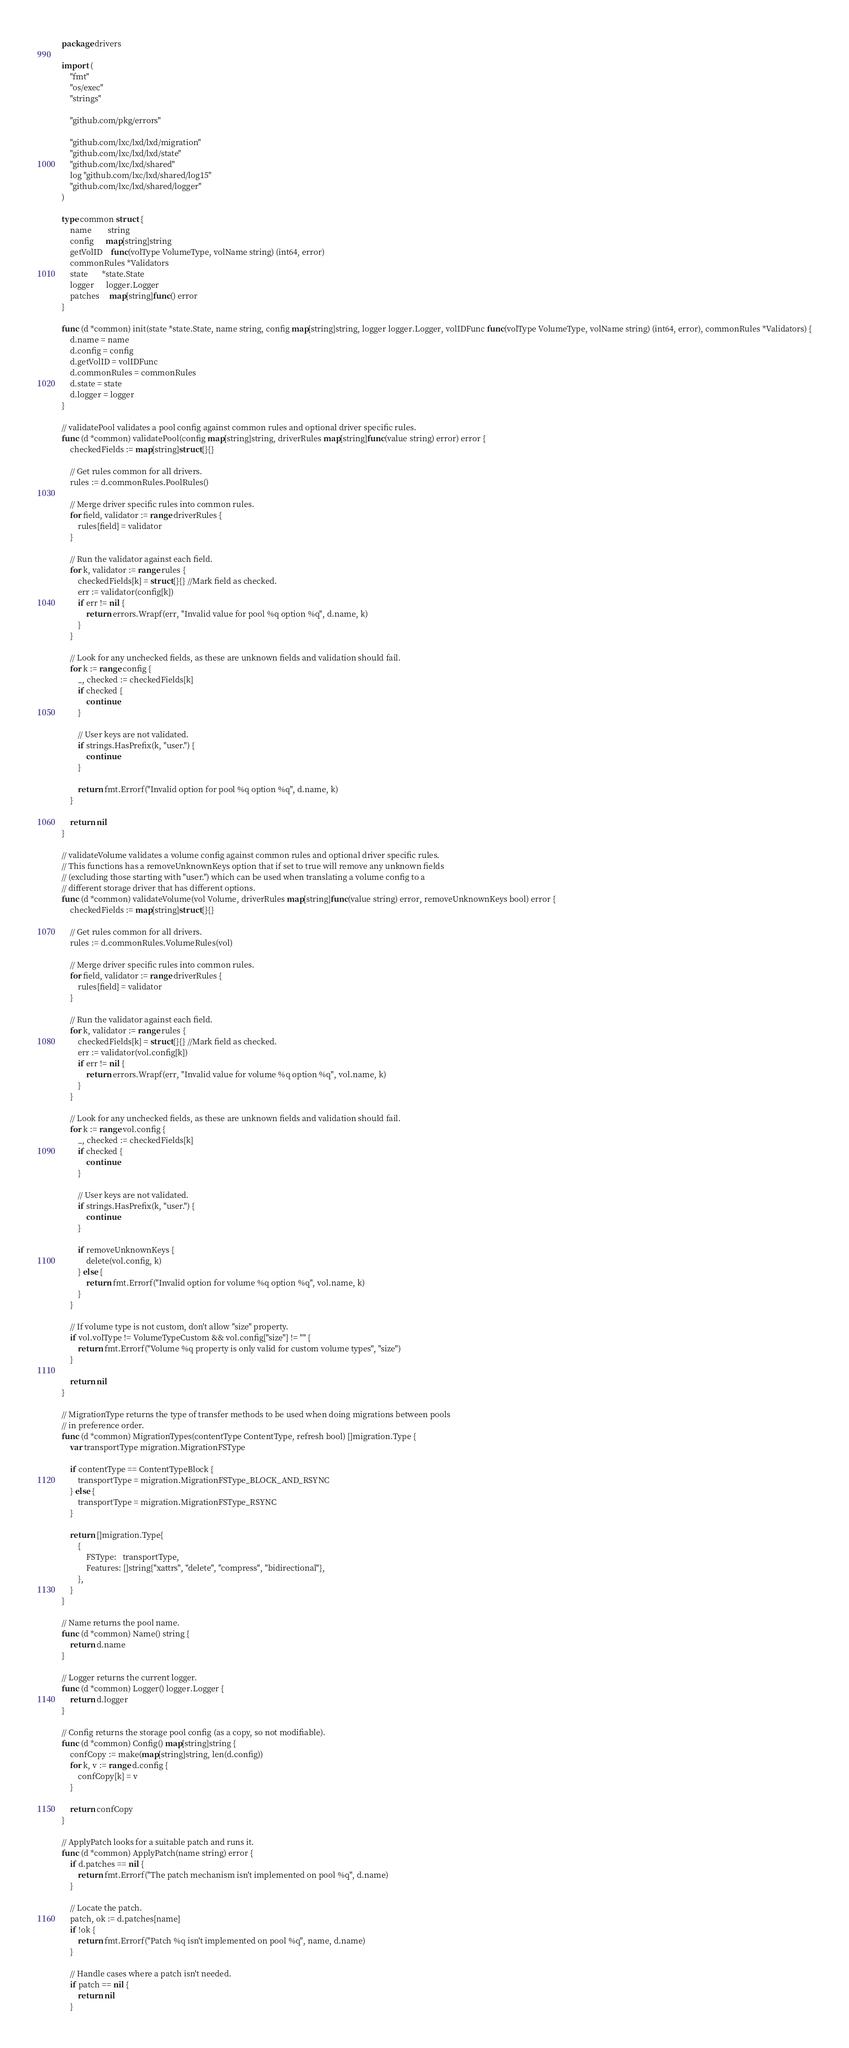Convert code to text. <code><loc_0><loc_0><loc_500><loc_500><_Go_>package drivers

import (
	"fmt"
	"os/exec"
	"strings"

	"github.com/pkg/errors"

	"github.com/lxc/lxd/lxd/migration"
	"github.com/lxc/lxd/lxd/state"
	"github.com/lxc/lxd/shared"
	log "github.com/lxc/lxd/shared/log15"
	"github.com/lxc/lxd/shared/logger"
)

type common struct {
	name        string
	config      map[string]string
	getVolID    func(volType VolumeType, volName string) (int64, error)
	commonRules *Validators
	state       *state.State
	logger      logger.Logger
	patches     map[string]func() error
}

func (d *common) init(state *state.State, name string, config map[string]string, logger logger.Logger, volIDFunc func(volType VolumeType, volName string) (int64, error), commonRules *Validators) {
	d.name = name
	d.config = config
	d.getVolID = volIDFunc
	d.commonRules = commonRules
	d.state = state
	d.logger = logger
}

// validatePool validates a pool config against common rules and optional driver specific rules.
func (d *common) validatePool(config map[string]string, driverRules map[string]func(value string) error) error {
	checkedFields := map[string]struct{}{}

	// Get rules common for all drivers.
	rules := d.commonRules.PoolRules()

	// Merge driver specific rules into common rules.
	for field, validator := range driverRules {
		rules[field] = validator
	}

	// Run the validator against each field.
	for k, validator := range rules {
		checkedFields[k] = struct{}{} //Mark field as checked.
		err := validator(config[k])
		if err != nil {
			return errors.Wrapf(err, "Invalid value for pool %q option %q", d.name, k)
		}
	}

	// Look for any unchecked fields, as these are unknown fields and validation should fail.
	for k := range config {
		_, checked := checkedFields[k]
		if checked {
			continue
		}

		// User keys are not validated.
		if strings.HasPrefix(k, "user.") {
			continue
		}

		return fmt.Errorf("Invalid option for pool %q option %q", d.name, k)
	}

	return nil
}

// validateVolume validates a volume config against common rules and optional driver specific rules.
// This functions has a removeUnknownKeys option that if set to true will remove any unknown fields
// (excluding those starting with "user.") which can be used when translating a volume config to a
// different storage driver that has different options.
func (d *common) validateVolume(vol Volume, driverRules map[string]func(value string) error, removeUnknownKeys bool) error {
	checkedFields := map[string]struct{}{}

	// Get rules common for all drivers.
	rules := d.commonRules.VolumeRules(vol)

	// Merge driver specific rules into common rules.
	for field, validator := range driverRules {
		rules[field] = validator
	}

	// Run the validator against each field.
	for k, validator := range rules {
		checkedFields[k] = struct{}{} //Mark field as checked.
		err := validator(vol.config[k])
		if err != nil {
			return errors.Wrapf(err, "Invalid value for volume %q option %q", vol.name, k)
		}
	}

	// Look for any unchecked fields, as these are unknown fields and validation should fail.
	for k := range vol.config {
		_, checked := checkedFields[k]
		if checked {
			continue
		}

		// User keys are not validated.
		if strings.HasPrefix(k, "user.") {
			continue
		}

		if removeUnknownKeys {
			delete(vol.config, k)
		} else {
			return fmt.Errorf("Invalid option for volume %q option %q", vol.name, k)
		}
	}

	// If volume type is not custom, don't allow "size" property.
	if vol.volType != VolumeTypeCustom && vol.config["size"] != "" {
		return fmt.Errorf("Volume %q property is only valid for custom volume types", "size")
	}

	return nil
}

// MigrationType returns the type of transfer methods to be used when doing migrations between pools
// in preference order.
func (d *common) MigrationTypes(contentType ContentType, refresh bool) []migration.Type {
	var transportType migration.MigrationFSType

	if contentType == ContentTypeBlock {
		transportType = migration.MigrationFSType_BLOCK_AND_RSYNC
	} else {
		transportType = migration.MigrationFSType_RSYNC
	}

	return []migration.Type{
		{
			FSType:   transportType,
			Features: []string{"xattrs", "delete", "compress", "bidirectional"},
		},
	}
}

// Name returns the pool name.
func (d *common) Name() string {
	return d.name
}

// Logger returns the current logger.
func (d *common) Logger() logger.Logger {
	return d.logger
}

// Config returns the storage pool config (as a copy, so not modifiable).
func (d *common) Config() map[string]string {
	confCopy := make(map[string]string, len(d.config))
	for k, v := range d.config {
		confCopy[k] = v
	}

	return confCopy
}

// ApplyPatch looks for a suitable patch and runs it.
func (d *common) ApplyPatch(name string) error {
	if d.patches == nil {
		return fmt.Errorf("The patch mechanism isn't implemented on pool %q", d.name)
	}

	// Locate the patch.
	patch, ok := d.patches[name]
	if !ok {
		return fmt.Errorf("Patch %q isn't implemented on pool %q", name, d.name)
	}

	// Handle cases where a patch isn't needed.
	if patch == nil {
		return nil
	}
</code> 